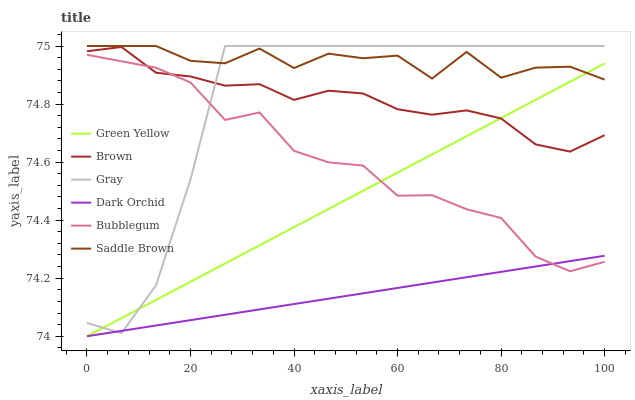Does Dark Orchid have the minimum area under the curve?
Answer yes or no. Yes. Does Saddle Brown have the maximum area under the curve?
Answer yes or no. Yes. Does Gray have the minimum area under the curve?
Answer yes or no. No. Does Gray have the maximum area under the curve?
Answer yes or no. No. Is Green Yellow the smoothest?
Answer yes or no. Yes. Is Saddle Brown the roughest?
Answer yes or no. Yes. Is Gray the smoothest?
Answer yes or no. No. Is Gray the roughest?
Answer yes or no. No. Does Gray have the lowest value?
Answer yes or no. No. Does Saddle Brown have the highest value?
Answer yes or no. Yes. Does Bubblegum have the highest value?
Answer yes or no. No. Is Bubblegum less than Saddle Brown?
Answer yes or no. Yes. Is Saddle Brown greater than Dark Orchid?
Answer yes or no. Yes. Does Gray intersect Green Yellow?
Answer yes or no. Yes. Is Gray less than Green Yellow?
Answer yes or no. No. Is Gray greater than Green Yellow?
Answer yes or no. No. Does Bubblegum intersect Saddle Brown?
Answer yes or no. No. 